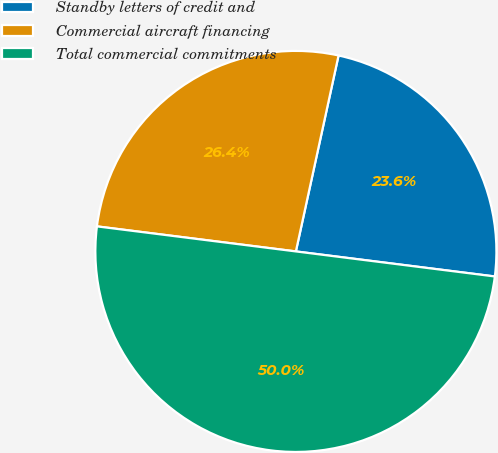<chart> <loc_0><loc_0><loc_500><loc_500><pie_chart><fcel>Standby letters of credit and<fcel>Commercial aircraft financing<fcel>Total commercial commitments<nl><fcel>23.58%<fcel>26.42%<fcel>50.0%<nl></chart> 